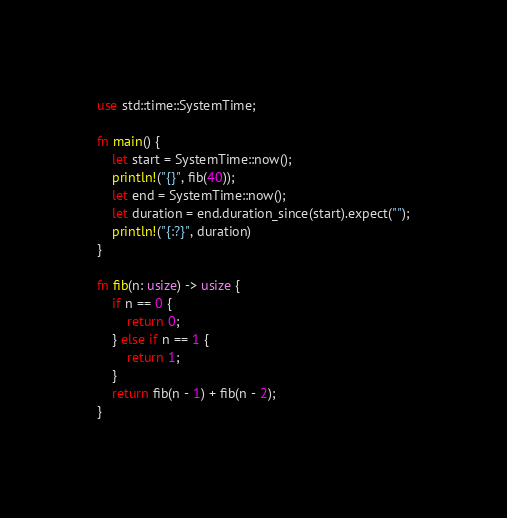Convert code to text. <code><loc_0><loc_0><loc_500><loc_500><_Rust_>use std::time::SystemTime;

fn main() {
    let start = SystemTime::now();
    println!("{}", fib(40));
    let end = SystemTime::now();
    let duration = end.duration_since(start).expect("");
    println!("{:?}", duration)
}

fn fib(n: usize) -> usize {
    if n == 0 {
        return 0;
    } else if n == 1 {
        return 1;
    }
    return fib(n - 1) + fib(n - 2);
}
</code> 